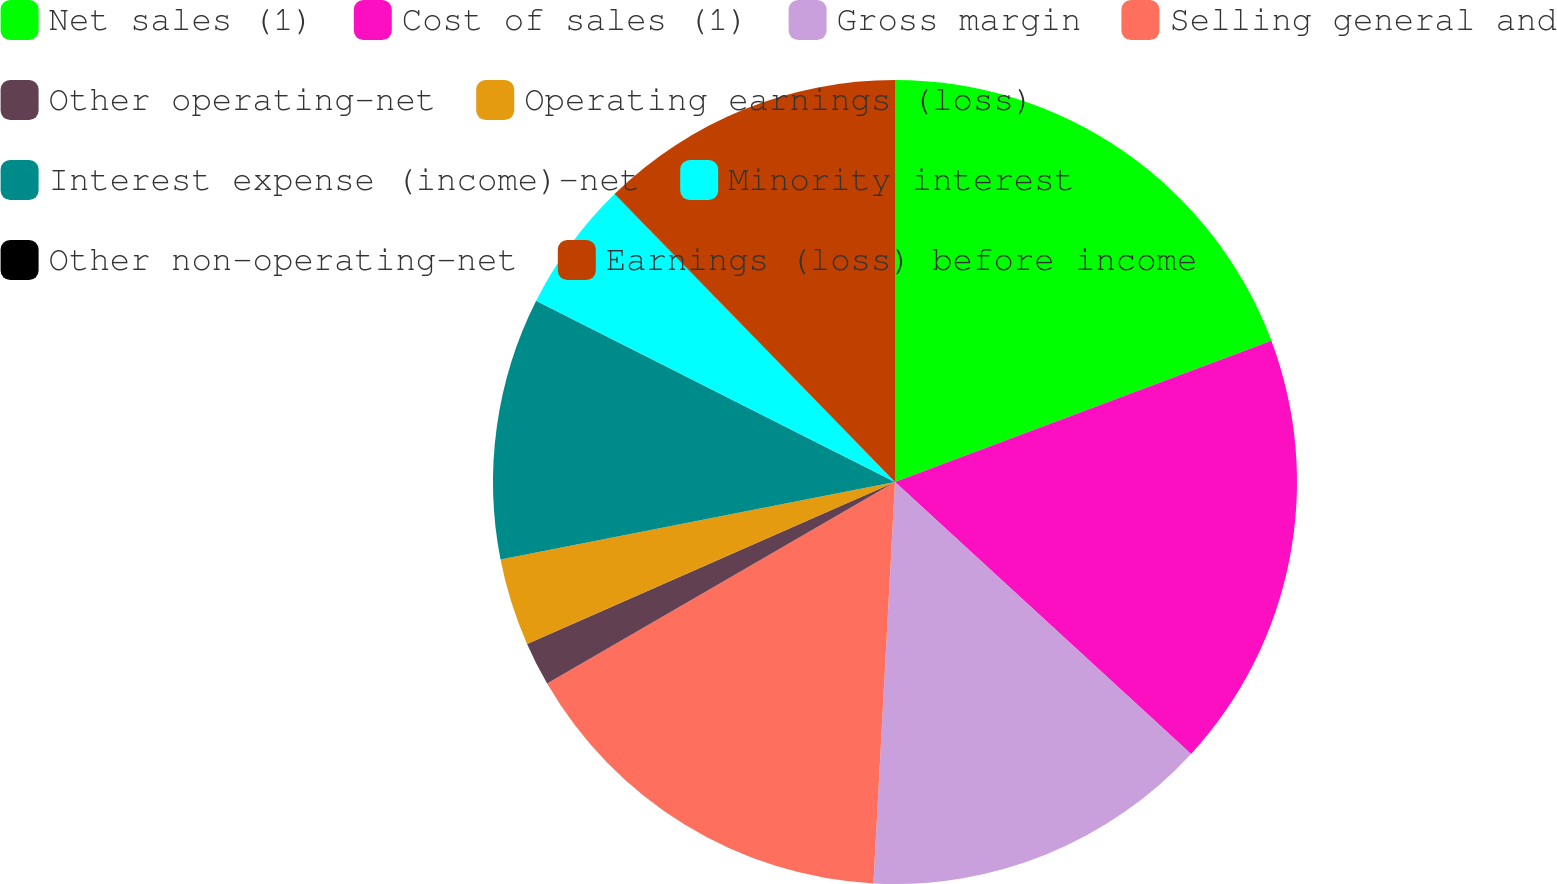<chart> <loc_0><loc_0><loc_500><loc_500><pie_chart><fcel>Net sales (1)<fcel>Cost of sales (1)<fcel>Gross margin<fcel>Selling general and<fcel>Other operating-net<fcel>Operating earnings (loss)<fcel>Interest expense (income)-net<fcel>Minority interest<fcel>Other non-operating-net<fcel>Earnings (loss) before income<nl><fcel>19.29%<fcel>17.54%<fcel>14.03%<fcel>15.79%<fcel>1.76%<fcel>3.51%<fcel>10.53%<fcel>5.27%<fcel>0.01%<fcel>12.28%<nl></chart> 